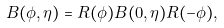<formula> <loc_0><loc_0><loc_500><loc_500>B ( \phi , \eta ) = R ( \phi ) B ( 0 , \eta ) R ( - \phi ) ,</formula> 